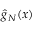Convert formula to latex. <formula><loc_0><loc_0><loc_500><loc_500>{ \hat { g } } _ { N } ( x )</formula> 